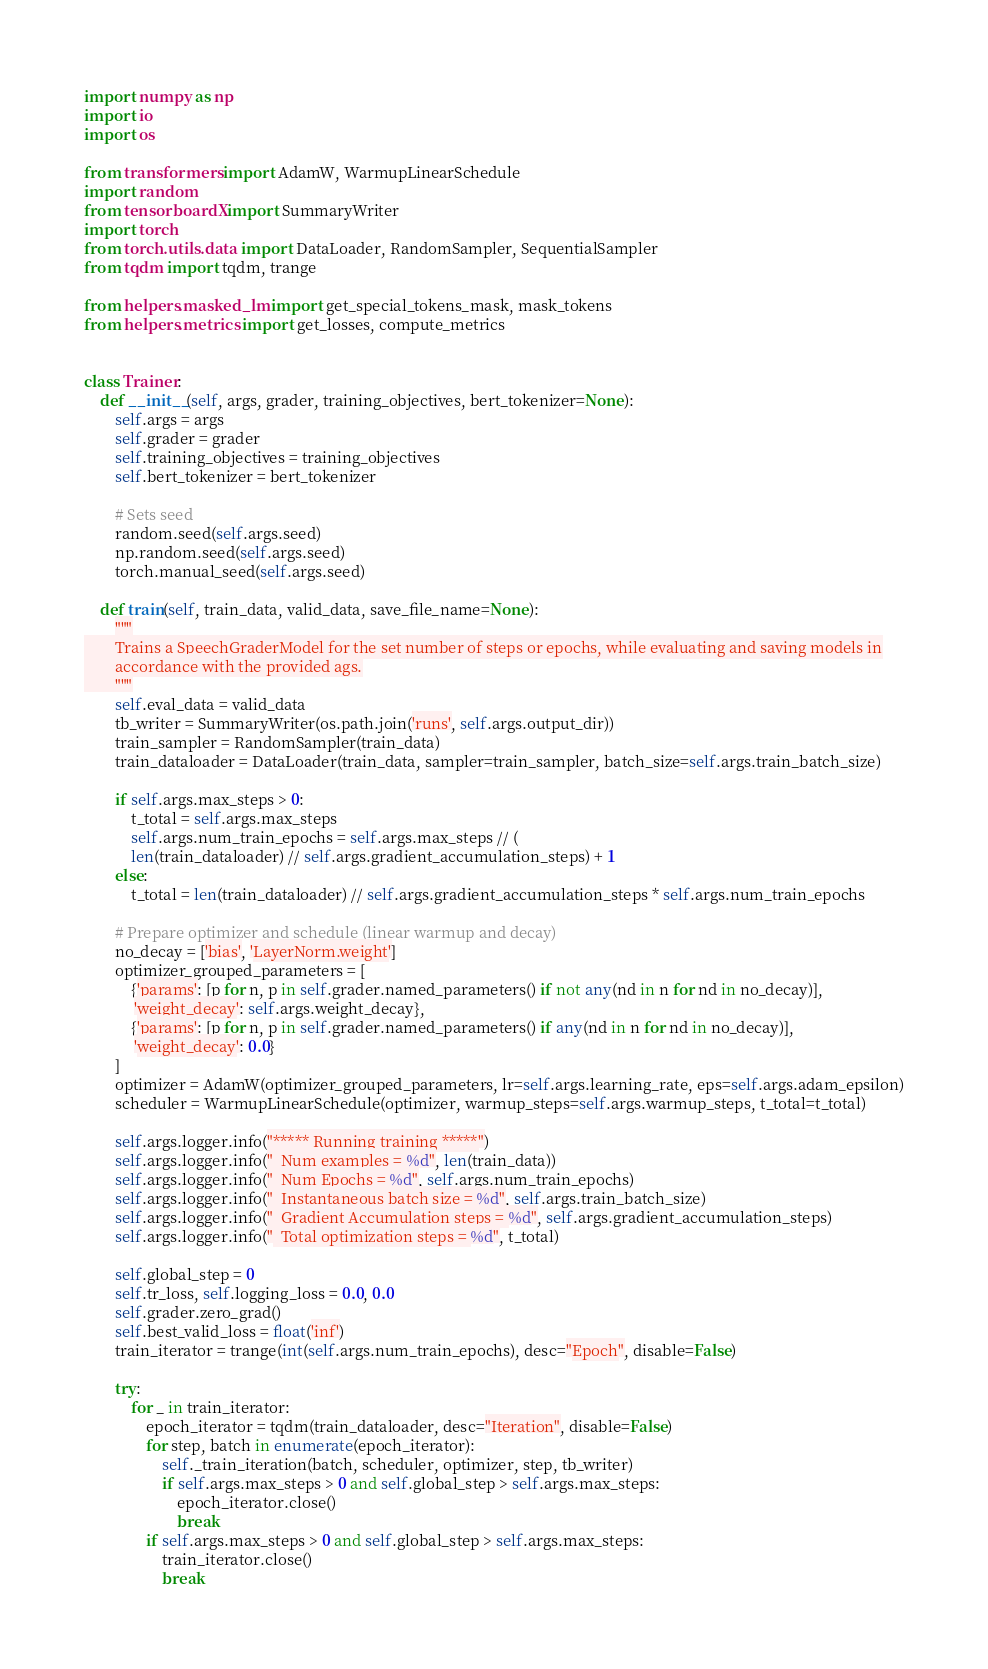Convert code to text. <code><loc_0><loc_0><loc_500><loc_500><_Python_>import numpy as np
import io
import os

from transformers import AdamW, WarmupLinearSchedule
import random
from tensorboardX import SummaryWriter
import torch
from torch.utils.data import DataLoader, RandomSampler, SequentialSampler
from tqdm import tqdm, trange

from helpers.masked_lm import get_special_tokens_mask, mask_tokens
from helpers.metrics import get_losses, compute_metrics


class Trainer:
    def __init__(self, args, grader, training_objectives, bert_tokenizer=None):
        self.args = args
        self.grader = grader
        self.training_objectives = training_objectives
        self.bert_tokenizer = bert_tokenizer

        # Sets seed
        random.seed(self.args.seed)
        np.random.seed(self.args.seed)
        torch.manual_seed(self.args.seed)

    def train(self, train_data, valid_data, save_file_name=None):
        """
        Trains a SpeechGraderModel for the set number of steps or epochs, while evaluating and saving models in
        accordance with the provided ags.
        """
        self.eval_data = valid_data
        tb_writer = SummaryWriter(os.path.join('runs', self.args.output_dir))
        train_sampler = RandomSampler(train_data)
        train_dataloader = DataLoader(train_data, sampler=train_sampler, batch_size=self.args.train_batch_size)

        if self.args.max_steps > 0:
            t_total = self.args.max_steps
            self.args.num_train_epochs = self.args.max_steps // (
            len(train_dataloader) // self.args.gradient_accumulation_steps) + 1
        else:
            t_total = len(train_dataloader) // self.args.gradient_accumulation_steps * self.args.num_train_epochs

        # Prepare optimizer and schedule (linear warmup and decay)
        no_decay = ['bias', 'LayerNorm.weight']
        optimizer_grouped_parameters = [
            {'params': [p for n, p in self.grader.named_parameters() if not any(nd in n for nd in no_decay)],
             'weight_decay': self.args.weight_decay},
            {'params': [p for n, p in self.grader.named_parameters() if any(nd in n for nd in no_decay)],
             'weight_decay': 0.0}
        ]
        optimizer = AdamW(optimizer_grouped_parameters, lr=self.args.learning_rate, eps=self.args.adam_epsilon)
        scheduler = WarmupLinearSchedule(optimizer, warmup_steps=self.args.warmup_steps, t_total=t_total)

        self.args.logger.info("***** Running training *****")
        self.args.logger.info("  Num examples = %d", len(train_data))
        self.args.logger.info("  Num Epochs = %d", self.args.num_train_epochs)
        self.args.logger.info("  Instantaneous batch size = %d", self.args.train_batch_size)
        self.args.logger.info("  Gradient Accumulation steps = %d", self.args.gradient_accumulation_steps)
        self.args.logger.info("  Total optimization steps = %d", t_total)

        self.global_step = 0
        self.tr_loss, self.logging_loss = 0.0, 0.0
        self.grader.zero_grad()
        self.best_valid_loss = float('inf')
        train_iterator = trange(int(self.args.num_train_epochs), desc="Epoch", disable=False)

        try:
            for _ in train_iterator:
                epoch_iterator = tqdm(train_dataloader, desc="Iteration", disable=False)
                for step, batch in enumerate(epoch_iterator):
                    self._train_iteration(batch, scheduler, optimizer, step, tb_writer)
                    if self.args.max_steps > 0 and self.global_step > self.args.max_steps:
                        epoch_iterator.close()
                        break
                if self.args.max_steps > 0 and self.global_step > self.args.max_steps:
                    train_iterator.close()
                    break
</code> 